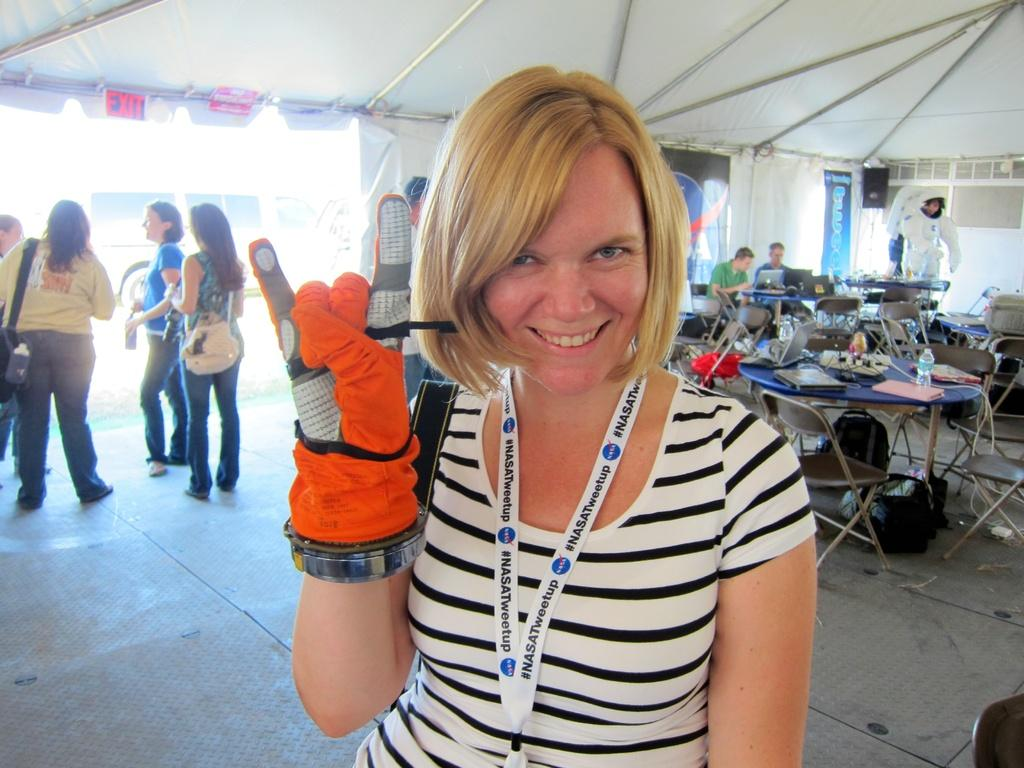Who or what can be seen in the image? There are people in the image. What type of furniture is present in the image? There are chairs and tables in the image. What items are on the tables? There are files, bottles, and a projector on the tables. Can you see any cattle in the image? There is no cattle present in the image. What type of cake is being served at the meeting in the image? There is no cake present in the image; it features people, chairs, tables, files, bottles, and a projector. 